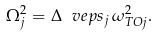Convert formula to latex. <formula><loc_0><loc_0><loc_500><loc_500>\Omega ^ { 2 } _ { j } = \Delta \ v e p s _ { j } \, \omega ^ { 2 } _ { T O j } .</formula> 